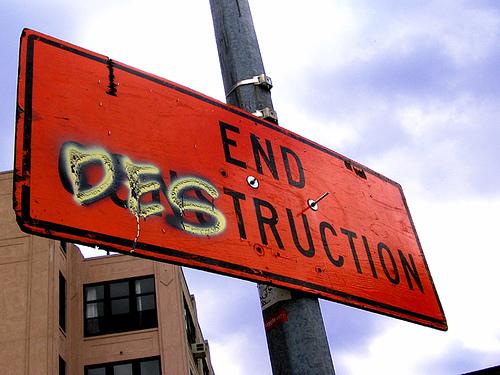Has this sign been modified?
Give a very brief answer. Yes. Is this a directional sign or a landmark sign?
Give a very brief answer. Directional. What letters were replaced by DES?
Short answer required. Cons. What is the first word?
Keep it brief. End. Which street sign is bent?
Concise answer only. None. What does the sign say?
Keep it brief. End destruction. 